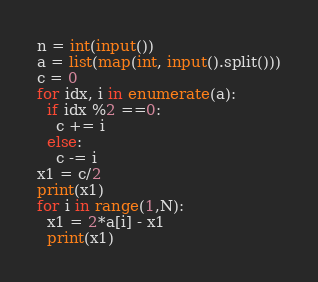Convert code to text. <code><loc_0><loc_0><loc_500><loc_500><_Python_>n = int(input())
a = list(map(int, input().split()))
c = 0
for idx, i in enumerate(a):
  if idx %2 ==0:
    c += i
  else: 
    c -= i
x1 = c/2
print(x1)
for i in range(1,N):
  x1 = 2*a[i] - x1
  print(x1)
</code> 